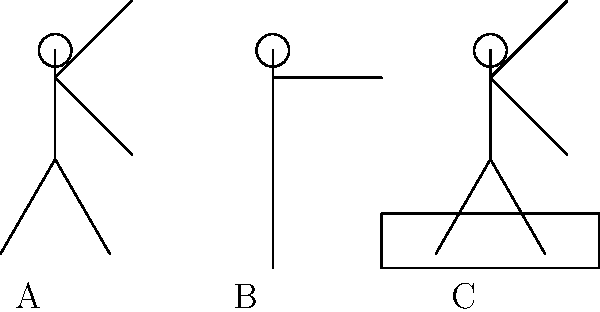Which of the stick figures (A, B, or C) demonstrates the correct body posture for lifting a heavy object, as shown by the box near figure C? To determine the correct lifting technique, let's analyze each stick figure:

1. Figure A:
   - Bent knees and hips
   - Back is relatively straight
   - Arms are close to the body
   - This posture allows for using leg muscles and maintaining a neutral spine

2. Figure B:
   - Standing straight
   - Arms at sides
   - Not in a lifting position
   - This posture is not suitable for lifting

3. Figure C:
   - Bent forward at the waist
   - Straight legs
   - Arms reaching down
   - This posture puts excessive strain on the lower back and increases injury risk

The correct lifting technique involves:
1. Keeping the back straight and chest up
2. Bending at the knees and hips
3. Keeping the load close to the body
4. Using leg muscles to lift
5. Avoiding twisting while lifting

Figure A demonstrates these principles, making it the safest and most biomechanically sound option for lifting the box.
Answer: A 